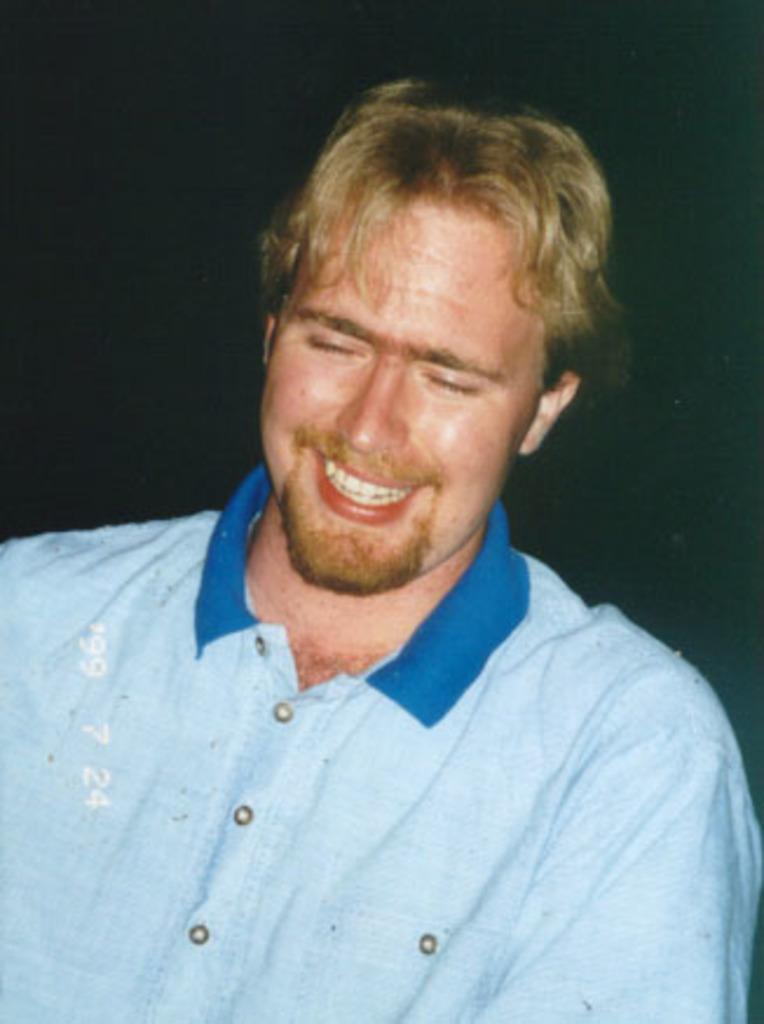What is the overall color scheme of the image? The background of the image is dark. Who is the main subject in the image? There is a man in the middle of the image. What is the man's facial expression? The man has a smiling face. What color is the man's T-shirt? The man is wearing a blue T-shirt. What type of wool is being spun by the man in the image? There is no wool or spinning activity present in the image; the man is simply wearing a blue T-shirt. 